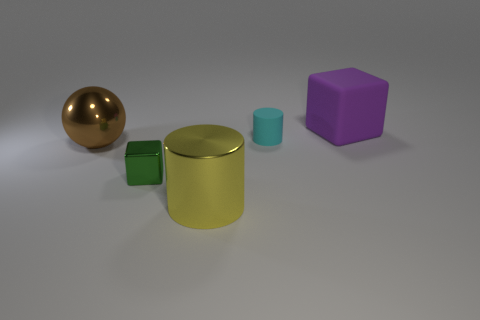Can you tell me the different colors of the objects starting from the left? Certainly! From left to right, the first object is a shiny brown sphere, followed by a yellow cylinder. Next to the cylinder is a small green cube, and on the right, there is a small cyan cylinder and a purple cube. 